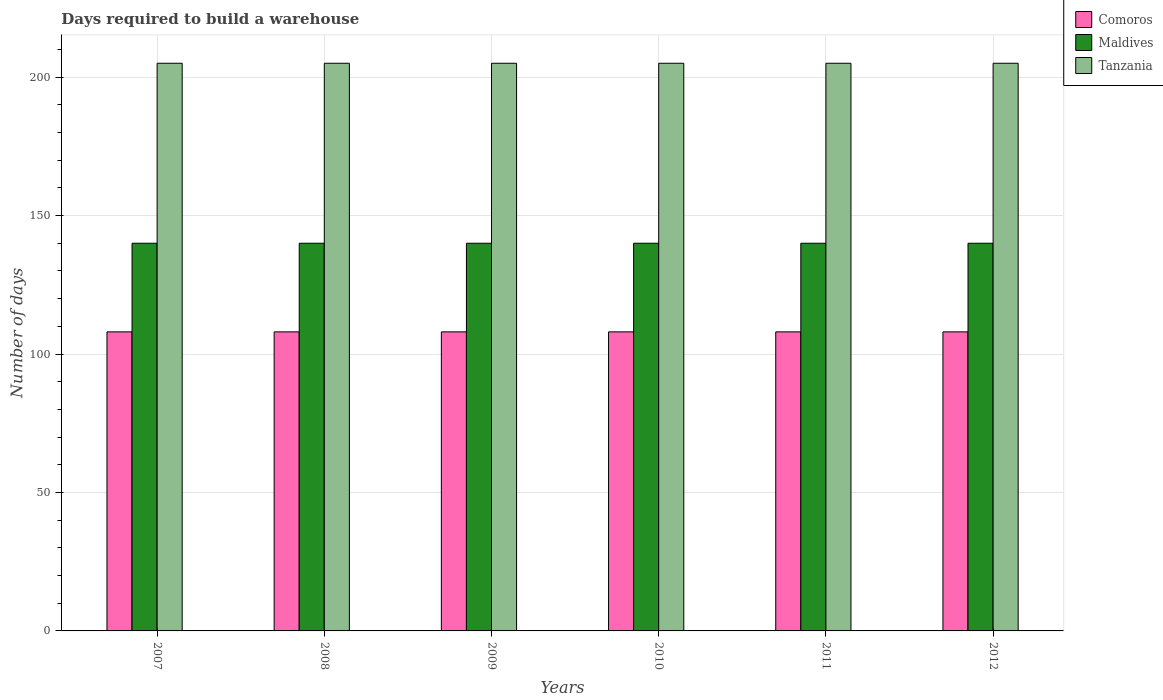Are the number of bars per tick equal to the number of legend labels?
Give a very brief answer. Yes. How many bars are there on the 2nd tick from the left?
Your response must be concise. 3. How many bars are there on the 3rd tick from the right?
Give a very brief answer. 3. What is the label of the 3rd group of bars from the left?
Ensure brevity in your answer.  2009. What is the days required to build a warehouse in in Tanzania in 2009?
Give a very brief answer. 205. Across all years, what is the maximum days required to build a warehouse in in Comoros?
Make the answer very short. 108. Across all years, what is the minimum days required to build a warehouse in in Tanzania?
Provide a short and direct response. 205. In which year was the days required to build a warehouse in in Tanzania maximum?
Offer a very short reply. 2007. In which year was the days required to build a warehouse in in Comoros minimum?
Your answer should be compact. 2007. What is the total days required to build a warehouse in in Maldives in the graph?
Ensure brevity in your answer.  840. What is the difference between the days required to build a warehouse in in Comoros in 2007 and the days required to build a warehouse in in Tanzania in 2008?
Your response must be concise. -97. What is the average days required to build a warehouse in in Tanzania per year?
Ensure brevity in your answer.  205. In the year 2011, what is the difference between the days required to build a warehouse in in Tanzania and days required to build a warehouse in in Comoros?
Keep it short and to the point. 97. In how many years, is the days required to build a warehouse in in Comoros greater than 120 days?
Your answer should be very brief. 0. What is the ratio of the days required to build a warehouse in in Maldives in 2008 to that in 2009?
Your answer should be compact. 1. Is the days required to build a warehouse in in Tanzania in 2010 less than that in 2012?
Give a very brief answer. No. Is the difference between the days required to build a warehouse in in Tanzania in 2007 and 2012 greater than the difference between the days required to build a warehouse in in Comoros in 2007 and 2012?
Make the answer very short. No. What is the difference between the highest and the second highest days required to build a warehouse in in Comoros?
Offer a terse response. 0. What is the difference between the highest and the lowest days required to build a warehouse in in Comoros?
Offer a terse response. 0. In how many years, is the days required to build a warehouse in in Comoros greater than the average days required to build a warehouse in in Comoros taken over all years?
Your response must be concise. 0. What does the 3rd bar from the left in 2012 represents?
Your response must be concise. Tanzania. What does the 1st bar from the right in 2010 represents?
Your answer should be compact. Tanzania. Are the values on the major ticks of Y-axis written in scientific E-notation?
Give a very brief answer. No. Does the graph contain any zero values?
Your answer should be compact. No. What is the title of the graph?
Provide a short and direct response. Days required to build a warehouse. What is the label or title of the X-axis?
Provide a short and direct response. Years. What is the label or title of the Y-axis?
Your answer should be compact. Number of days. What is the Number of days of Comoros in 2007?
Offer a terse response. 108. What is the Number of days in Maldives in 2007?
Your answer should be very brief. 140. What is the Number of days in Tanzania in 2007?
Your answer should be very brief. 205. What is the Number of days in Comoros in 2008?
Give a very brief answer. 108. What is the Number of days of Maldives in 2008?
Provide a short and direct response. 140. What is the Number of days in Tanzania in 2008?
Make the answer very short. 205. What is the Number of days of Comoros in 2009?
Your answer should be compact. 108. What is the Number of days in Maldives in 2009?
Provide a succinct answer. 140. What is the Number of days in Tanzania in 2009?
Provide a succinct answer. 205. What is the Number of days in Comoros in 2010?
Provide a succinct answer. 108. What is the Number of days of Maldives in 2010?
Offer a very short reply. 140. What is the Number of days in Tanzania in 2010?
Keep it short and to the point. 205. What is the Number of days of Comoros in 2011?
Ensure brevity in your answer.  108. What is the Number of days in Maldives in 2011?
Give a very brief answer. 140. What is the Number of days in Tanzania in 2011?
Ensure brevity in your answer.  205. What is the Number of days of Comoros in 2012?
Provide a succinct answer. 108. What is the Number of days of Maldives in 2012?
Your answer should be very brief. 140. What is the Number of days of Tanzania in 2012?
Ensure brevity in your answer.  205. Across all years, what is the maximum Number of days in Comoros?
Offer a very short reply. 108. Across all years, what is the maximum Number of days of Maldives?
Provide a succinct answer. 140. Across all years, what is the maximum Number of days in Tanzania?
Your answer should be very brief. 205. Across all years, what is the minimum Number of days of Comoros?
Offer a terse response. 108. Across all years, what is the minimum Number of days in Maldives?
Provide a succinct answer. 140. Across all years, what is the minimum Number of days in Tanzania?
Ensure brevity in your answer.  205. What is the total Number of days of Comoros in the graph?
Provide a short and direct response. 648. What is the total Number of days of Maldives in the graph?
Make the answer very short. 840. What is the total Number of days in Tanzania in the graph?
Provide a short and direct response. 1230. What is the difference between the Number of days of Maldives in 2007 and that in 2008?
Give a very brief answer. 0. What is the difference between the Number of days of Tanzania in 2007 and that in 2008?
Offer a terse response. 0. What is the difference between the Number of days of Tanzania in 2007 and that in 2009?
Offer a very short reply. 0. What is the difference between the Number of days of Maldives in 2007 and that in 2010?
Your response must be concise. 0. What is the difference between the Number of days in Maldives in 2007 and that in 2011?
Make the answer very short. 0. What is the difference between the Number of days of Comoros in 2007 and that in 2012?
Offer a very short reply. 0. What is the difference between the Number of days in Maldives in 2007 and that in 2012?
Offer a very short reply. 0. What is the difference between the Number of days of Tanzania in 2007 and that in 2012?
Offer a terse response. 0. What is the difference between the Number of days of Comoros in 2008 and that in 2009?
Ensure brevity in your answer.  0. What is the difference between the Number of days of Tanzania in 2008 and that in 2009?
Your answer should be compact. 0. What is the difference between the Number of days in Maldives in 2008 and that in 2011?
Your answer should be very brief. 0. What is the difference between the Number of days in Tanzania in 2008 and that in 2011?
Offer a very short reply. 0. What is the difference between the Number of days in Comoros in 2008 and that in 2012?
Offer a terse response. 0. What is the difference between the Number of days in Maldives in 2008 and that in 2012?
Make the answer very short. 0. What is the difference between the Number of days in Comoros in 2009 and that in 2010?
Offer a terse response. 0. What is the difference between the Number of days of Maldives in 2009 and that in 2010?
Provide a succinct answer. 0. What is the difference between the Number of days in Tanzania in 2009 and that in 2010?
Give a very brief answer. 0. What is the difference between the Number of days of Maldives in 2009 and that in 2011?
Provide a succinct answer. 0. What is the difference between the Number of days in Comoros in 2009 and that in 2012?
Offer a very short reply. 0. What is the difference between the Number of days of Maldives in 2009 and that in 2012?
Make the answer very short. 0. What is the difference between the Number of days in Comoros in 2010 and that in 2011?
Offer a very short reply. 0. What is the difference between the Number of days of Comoros in 2010 and that in 2012?
Your answer should be very brief. 0. What is the difference between the Number of days in Maldives in 2010 and that in 2012?
Your answer should be very brief. 0. What is the difference between the Number of days of Comoros in 2007 and the Number of days of Maldives in 2008?
Provide a succinct answer. -32. What is the difference between the Number of days in Comoros in 2007 and the Number of days in Tanzania in 2008?
Keep it short and to the point. -97. What is the difference between the Number of days in Maldives in 2007 and the Number of days in Tanzania in 2008?
Offer a terse response. -65. What is the difference between the Number of days in Comoros in 2007 and the Number of days in Maldives in 2009?
Offer a very short reply. -32. What is the difference between the Number of days of Comoros in 2007 and the Number of days of Tanzania in 2009?
Provide a short and direct response. -97. What is the difference between the Number of days of Maldives in 2007 and the Number of days of Tanzania in 2009?
Your answer should be compact. -65. What is the difference between the Number of days in Comoros in 2007 and the Number of days in Maldives in 2010?
Provide a succinct answer. -32. What is the difference between the Number of days in Comoros in 2007 and the Number of days in Tanzania in 2010?
Keep it short and to the point. -97. What is the difference between the Number of days of Maldives in 2007 and the Number of days of Tanzania in 2010?
Your answer should be very brief. -65. What is the difference between the Number of days of Comoros in 2007 and the Number of days of Maldives in 2011?
Your answer should be compact. -32. What is the difference between the Number of days of Comoros in 2007 and the Number of days of Tanzania in 2011?
Offer a terse response. -97. What is the difference between the Number of days of Maldives in 2007 and the Number of days of Tanzania in 2011?
Make the answer very short. -65. What is the difference between the Number of days in Comoros in 2007 and the Number of days in Maldives in 2012?
Keep it short and to the point. -32. What is the difference between the Number of days in Comoros in 2007 and the Number of days in Tanzania in 2012?
Offer a terse response. -97. What is the difference between the Number of days of Maldives in 2007 and the Number of days of Tanzania in 2012?
Offer a very short reply. -65. What is the difference between the Number of days in Comoros in 2008 and the Number of days in Maldives in 2009?
Keep it short and to the point. -32. What is the difference between the Number of days of Comoros in 2008 and the Number of days of Tanzania in 2009?
Make the answer very short. -97. What is the difference between the Number of days of Maldives in 2008 and the Number of days of Tanzania in 2009?
Keep it short and to the point. -65. What is the difference between the Number of days in Comoros in 2008 and the Number of days in Maldives in 2010?
Offer a terse response. -32. What is the difference between the Number of days in Comoros in 2008 and the Number of days in Tanzania in 2010?
Keep it short and to the point. -97. What is the difference between the Number of days in Maldives in 2008 and the Number of days in Tanzania in 2010?
Keep it short and to the point. -65. What is the difference between the Number of days in Comoros in 2008 and the Number of days in Maldives in 2011?
Make the answer very short. -32. What is the difference between the Number of days of Comoros in 2008 and the Number of days of Tanzania in 2011?
Make the answer very short. -97. What is the difference between the Number of days of Maldives in 2008 and the Number of days of Tanzania in 2011?
Offer a terse response. -65. What is the difference between the Number of days in Comoros in 2008 and the Number of days in Maldives in 2012?
Offer a very short reply. -32. What is the difference between the Number of days in Comoros in 2008 and the Number of days in Tanzania in 2012?
Make the answer very short. -97. What is the difference between the Number of days of Maldives in 2008 and the Number of days of Tanzania in 2012?
Ensure brevity in your answer.  -65. What is the difference between the Number of days of Comoros in 2009 and the Number of days of Maldives in 2010?
Give a very brief answer. -32. What is the difference between the Number of days of Comoros in 2009 and the Number of days of Tanzania in 2010?
Your answer should be very brief. -97. What is the difference between the Number of days in Maldives in 2009 and the Number of days in Tanzania in 2010?
Ensure brevity in your answer.  -65. What is the difference between the Number of days of Comoros in 2009 and the Number of days of Maldives in 2011?
Provide a short and direct response. -32. What is the difference between the Number of days of Comoros in 2009 and the Number of days of Tanzania in 2011?
Provide a succinct answer. -97. What is the difference between the Number of days of Maldives in 2009 and the Number of days of Tanzania in 2011?
Your answer should be compact. -65. What is the difference between the Number of days of Comoros in 2009 and the Number of days of Maldives in 2012?
Make the answer very short. -32. What is the difference between the Number of days of Comoros in 2009 and the Number of days of Tanzania in 2012?
Your response must be concise. -97. What is the difference between the Number of days in Maldives in 2009 and the Number of days in Tanzania in 2012?
Offer a terse response. -65. What is the difference between the Number of days in Comoros in 2010 and the Number of days in Maldives in 2011?
Give a very brief answer. -32. What is the difference between the Number of days in Comoros in 2010 and the Number of days in Tanzania in 2011?
Provide a succinct answer. -97. What is the difference between the Number of days in Maldives in 2010 and the Number of days in Tanzania in 2011?
Make the answer very short. -65. What is the difference between the Number of days of Comoros in 2010 and the Number of days of Maldives in 2012?
Make the answer very short. -32. What is the difference between the Number of days of Comoros in 2010 and the Number of days of Tanzania in 2012?
Offer a very short reply. -97. What is the difference between the Number of days of Maldives in 2010 and the Number of days of Tanzania in 2012?
Your response must be concise. -65. What is the difference between the Number of days in Comoros in 2011 and the Number of days in Maldives in 2012?
Ensure brevity in your answer.  -32. What is the difference between the Number of days in Comoros in 2011 and the Number of days in Tanzania in 2012?
Provide a succinct answer. -97. What is the difference between the Number of days of Maldives in 2011 and the Number of days of Tanzania in 2012?
Ensure brevity in your answer.  -65. What is the average Number of days in Comoros per year?
Your response must be concise. 108. What is the average Number of days in Maldives per year?
Your answer should be very brief. 140. What is the average Number of days in Tanzania per year?
Offer a very short reply. 205. In the year 2007, what is the difference between the Number of days in Comoros and Number of days in Maldives?
Ensure brevity in your answer.  -32. In the year 2007, what is the difference between the Number of days of Comoros and Number of days of Tanzania?
Offer a terse response. -97. In the year 2007, what is the difference between the Number of days in Maldives and Number of days in Tanzania?
Your answer should be compact. -65. In the year 2008, what is the difference between the Number of days in Comoros and Number of days in Maldives?
Your answer should be compact. -32. In the year 2008, what is the difference between the Number of days of Comoros and Number of days of Tanzania?
Offer a terse response. -97. In the year 2008, what is the difference between the Number of days of Maldives and Number of days of Tanzania?
Your response must be concise. -65. In the year 2009, what is the difference between the Number of days of Comoros and Number of days of Maldives?
Offer a terse response. -32. In the year 2009, what is the difference between the Number of days of Comoros and Number of days of Tanzania?
Offer a terse response. -97. In the year 2009, what is the difference between the Number of days of Maldives and Number of days of Tanzania?
Provide a short and direct response. -65. In the year 2010, what is the difference between the Number of days in Comoros and Number of days in Maldives?
Provide a succinct answer. -32. In the year 2010, what is the difference between the Number of days of Comoros and Number of days of Tanzania?
Give a very brief answer. -97. In the year 2010, what is the difference between the Number of days of Maldives and Number of days of Tanzania?
Provide a succinct answer. -65. In the year 2011, what is the difference between the Number of days of Comoros and Number of days of Maldives?
Your response must be concise. -32. In the year 2011, what is the difference between the Number of days in Comoros and Number of days in Tanzania?
Offer a very short reply. -97. In the year 2011, what is the difference between the Number of days in Maldives and Number of days in Tanzania?
Your response must be concise. -65. In the year 2012, what is the difference between the Number of days of Comoros and Number of days of Maldives?
Your answer should be very brief. -32. In the year 2012, what is the difference between the Number of days in Comoros and Number of days in Tanzania?
Your response must be concise. -97. In the year 2012, what is the difference between the Number of days of Maldives and Number of days of Tanzania?
Your response must be concise. -65. What is the ratio of the Number of days of Maldives in 2007 to that in 2008?
Your answer should be compact. 1. What is the ratio of the Number of days in Comoros in 2007 to that in 2009?
Keep it short and to the point. 1. What is the ratio of the Number of days in Maldives in 2007 to that in 2009?
Ensure brevity in your answer.  1. What is the ratio of the Number of days in Tanzania in 2007 to that in 2009?
Give a very brief answer. 1. What is the ratio of the Number of days in Maldives in 2007 to that in 2010?
Keep it short and to the point. 1. What is the ratio of the Number of days of Tanzania in 2007 to that in 2010?
Offer a very short reply. 1. What is the ratio of the Number of days in Comoros in 2007 to that in 2011?
Provide a succinct answer. 1. What is the ratio of the Number of days in Tanzania in 2007 to that in 2011?
Give a very brief answer. 1. What is the ratio of the Number of days of Maldives in 2008 to that in 2009?
Offer a very short reply. 1. What is the ratio of the Number of days in Tanzania in 2008 to that in 2009?
Keep it short and to the point. 1. What is the ratio of the Number of days in Comoros in 2008 to that in 2010?
Make the answer very short. 1. What is the ratio of the Number of days in Tanzania in 2008 to that in 2011?
Your answer should be very brief. 1. What is the ratio of the Number of days of Comoros in 2008 to that in 2012?
Keep it short and to the point. 1. What is the ratio of the Number of days in Maldives in 2008 to that in 2012?
Your answer should be compact. 1. What is the ratio of the Number of days of Comoros in 2009 to that in 2010?
Make the answer very short. 1. What is the ratio of the Number of days in Tanzania in 2009 to that in 2010?
Keep it short and to the point. 1. What is the ratio of the Number of days of Comoros in 2009 to that in 2011?
Give a very brief answer. 1. What is the ratio of the Number of days of Maldives in 2009 to that in 2011?
Ensure brevity in your answer.  1. What is the ratio of the Number of days of Tanzania in 2009 to that in 2011?
Make the answer very short. 1. What is the ratio of the Number of days in Maldives in 2009 to that in 2012?
Ensure brevity in your answer.  1. What is the ratio of the Number of days in Maldives in 2010 to that in 2011?
Ensure brevity in your answer.  1. What is the ratio of the Number of days of Maldives in 2011 to that in 2012?
Keep it short and to the point. 1. What is the difference between the highest and the second highest Number of days of Maldives?
Ensure brevity in your answer.  0. What is the difference between the highest and the second highest Number of days of Tanzania?
Your response must be concise. 0. What is the difference between the highest and the lowest Number of days in Tanzania?
Make the answer very short. 0. 